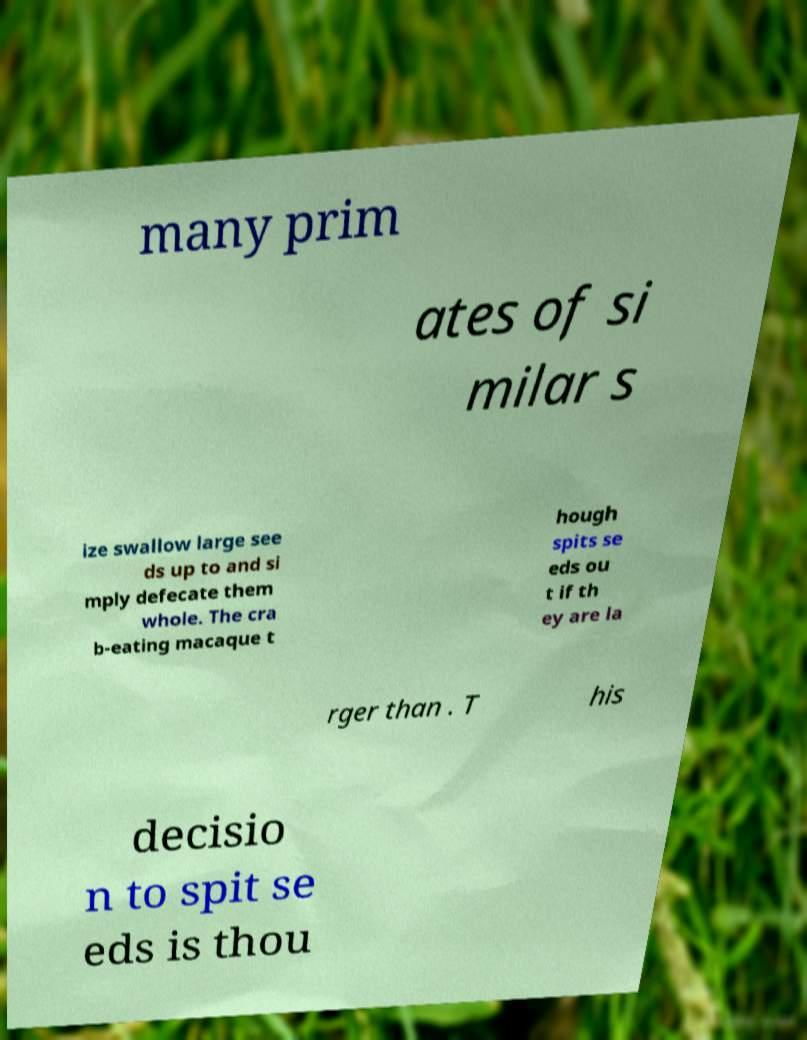For documentation purposes, I need the text within this image transcribed. Could you provide that? many prim ates of si milar s ize swallow large see ds up to and si mply defecate them whole. The cra b-eating macaque t hough spits se eds ou t if th ey are la rger than . T his decisio n to spit se eds is thou 